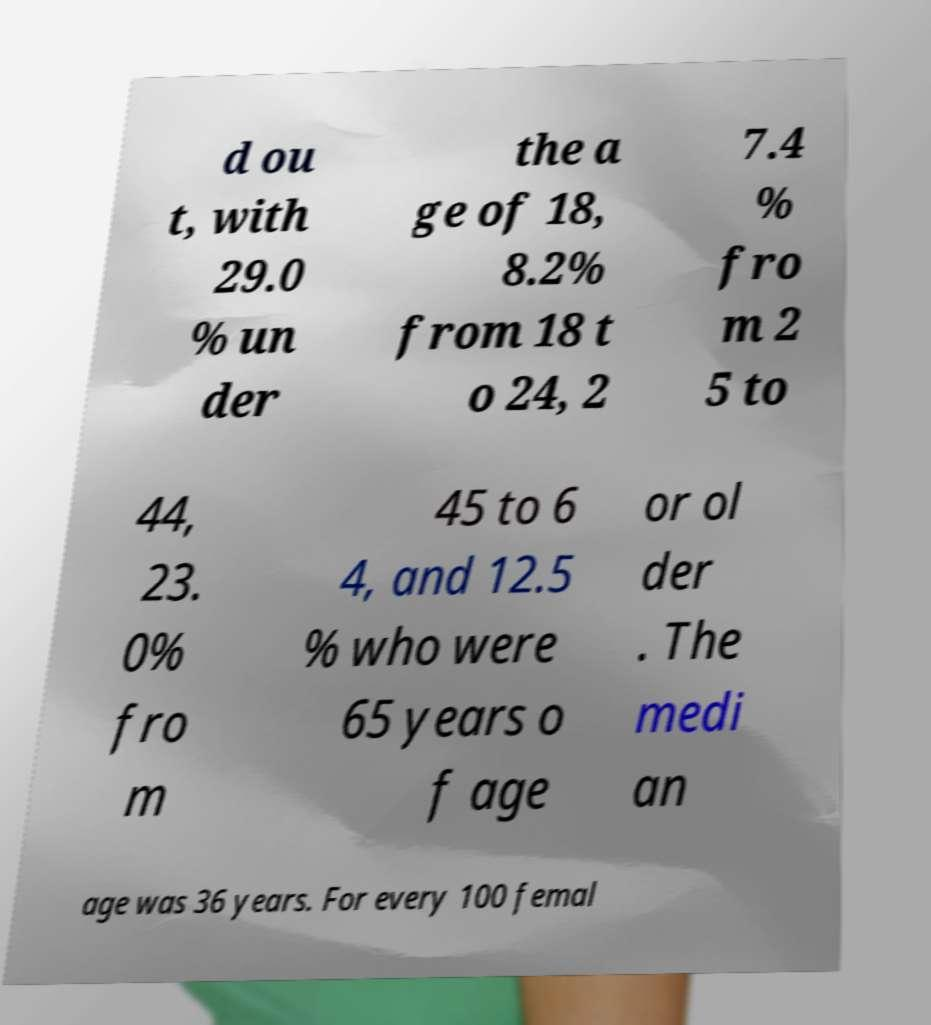Could you assist in decoding the text presented in this image and type it out clearly? d ou t, with 29.0 % un der the a ge of 18, 8.2% from 18 t o 24, 2 7.4 % fro m 2 5 to 44, 23. 0% fro m 45 to 6 4, and 12.5 % who were 65 years o f age or ol der . The medi an age was 36 years. For every 100 femal 